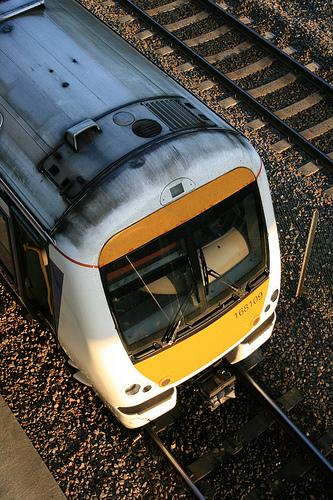Describe the quality of the image based on the object depiction. The image quality seems high, as it provides detailed depiction of various objects such as the train, its features, and elements of the train tracks with precision. What is the overall sentiment or emotion conveyed by the image? The overall sentiment of the image is neutral, as it is just depicting a train on railroad tracks without any emotional or vibrant elements. How would you describe the condition of the train and its surroundings? The train appears a bit worn with dirt and black marks on the top. It has some orange parts on the front as well. The railroad tracks have gravel, rocks, and brown pebbles on them, with a bush on the side of the track. Examine the image and list objects related to the train track. Objects related to the train track include rocks, gravel, brown pebbles, lines on the tracks, train tracks running parallel, a small pole in the middle of rails, and a bush on the side of the track. Analyze and describe the different interactions between the objects in the image. The train is moving along the tracks, which are laid on rocks and gravel, and surrounded by a bush and a small pole in between them. The windshield wipers on the front of the train are either cleaning or resting on the windshield that has a large window and yellow and black letters. Describe the appearance of the train in the image. The train is white and yellow with a large window on the front, a headlight, a side mirror, and black numbers "168109" on the front. The top of the train is dirty with black marks and vents. Identify the objects that are interacting with one another in the image. The train is interacting with the tracks it is on, and the wipers are interacting with the windshield on the front of the train. What objects can be found on the train? On the train, there are a headlight, side mirror, windshield wipers, black numbers, large window, yellow handle, and vents on the roof. Estimate the number of objects mentioned in the image. There are approximately 32 distinct objects mentioned in the image. Deduce the purpose of the train and the tracks in the image. The purpose of the train is likely to transport passengers or cargo, while the tracks are meant to guide and support the train's movement. 